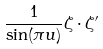<formula> <loc_0><loc_0><loc_500><loc_500>\frac { 1 } { \sin ( \pi u ) } \zeta \cdot \zeta ^ { \prime }</formula> 